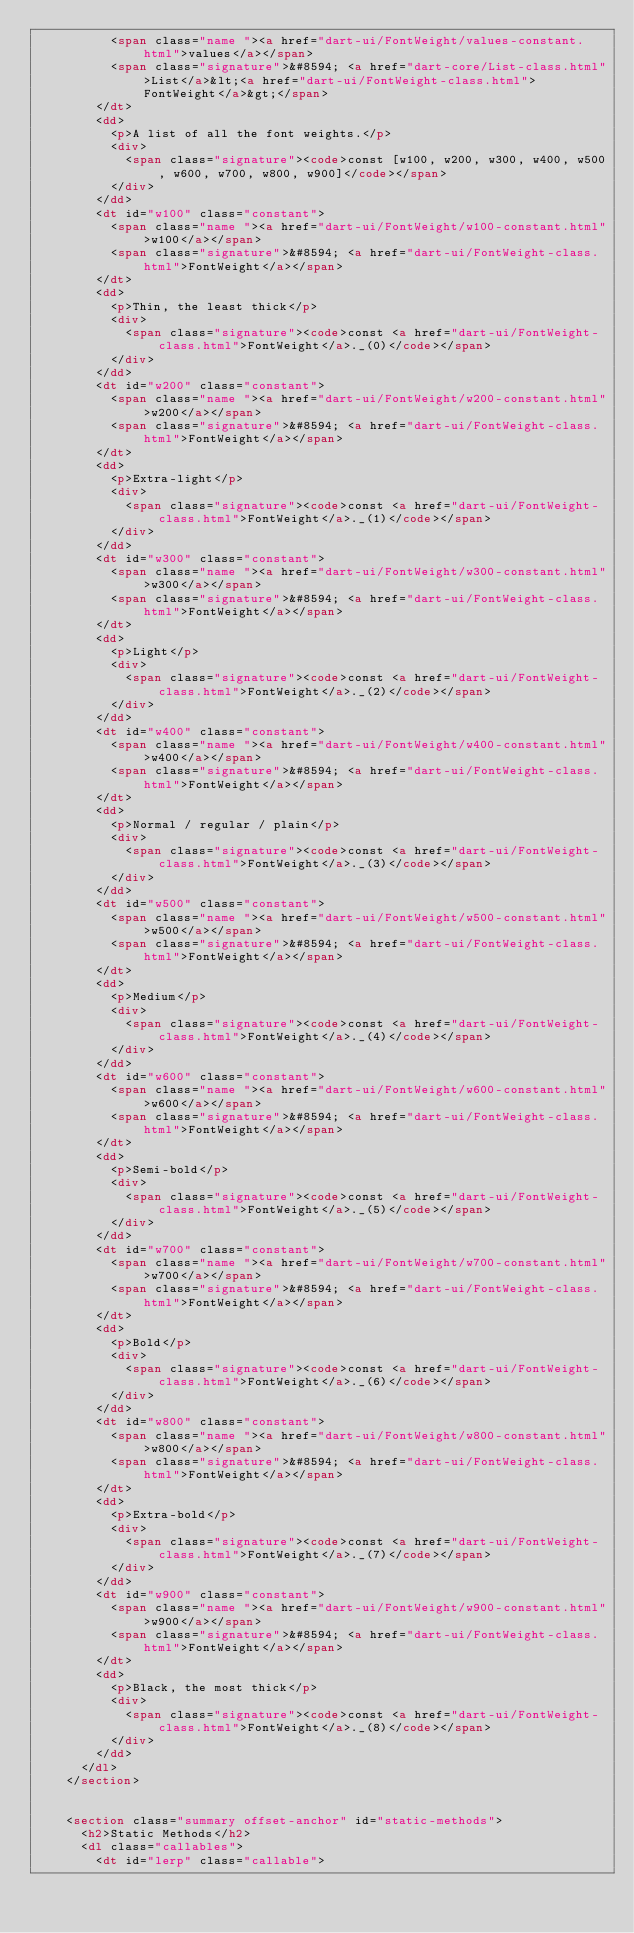Convert code to text. <code><loc_0><loc_0><loc_500><loc_500><_HTML_>          <span class="name "><a href="dart-ui/FontWeight/values-constant.html">values</a></span>
          <span class="signature">&#8594; <a href="dart-core/List-class.html">List</a>&lt;<a href="dart-ui/FontWeight-class.html">FontWeight</a>&gt;</span>
        </dt>
        <dd>
          <p>A list of all the font weights.</p>
          <div>
            <span class="signature"><code>const [w100, w200, w300, w400, w500, w600, w700, w800, w900]</code></span>
          </div>
        </dd>
        <dt id="w100" class="constant">
          <span class="name "><a href="dart-ui/FontWeight/w100-constant.html">w100</a></span>
          <span class="signature">&#8594; <a href="dart-ui/FontWeight-class.html">FontWeight</a></span>
        </dt>
        <dd>
          <p>Thin, the least thick</p>
          <div>
            <span class="signature"><code>const <a href="dart-ui/FontWeight-class.html">FontWeight</a>._(0)</code></span>
          </div>
        </dd>
        <dt id="w200" class="constant">
          <span class="name "><a href="dart-ui/FontWeight/w200-constant.html">w200</a></span>
          <span class="signature">&#8594; <a href="dart-ui/FontWeight-class.html">FontWeight</a></span>
        </dt>
        <dd>
          <p>Extra-light</p>
          <div>
            <span class="signature"><code>const <a href="dart-ui/FontWeight-class.html">FontWeight</a>._(1)</code></span>
          </div>
        </dd>
        <dt id="w300" class="constant">
          <span class="name "><a href="dart-ui/FontWeight/w300-constant.html">w300</a></span>
          <span class="signature">&#8594; <a href="dart-ui/FontWeight-class.html">FontWeight</a></span>
        </dt>
        <dd>
          <p>Light</p>
          <div>
            <span class="signature"><code>const <a href="dart-ui/FontWeight-class.html">FontWeight</a>._(2)</code></span>
          </div>
        </dd>
        <dt id="w400" class="constant">
          <span class="name "><a href="dart-ui/FontWeight/w400-constant.html">w400</a></span>
          <span class="signature">&#8594; <a href="dart-ui/FontWeight-class.html">FontWeight</a></span>
        </dt>
        <dd>
          <p>Normal / regular / plain</p>
          <div>
            <span class="signature"><code>const <a href="dart-ui/FontWeight-class.html">FontWeight</a>._(3)</code></span>
          </div>
        </dd>
        <dt id="w500" class="constant">
          <span class="name "><a href="dart-ui/FontWeight/w500-constant.html">w500</a></span>
          <span class="signature">&#8594; <a href="dart-ui/FontWeight-class.html">FontWeight</a></span>
        </dt>
        <dd>
          <p>Medium</p>
          <div>
            <span class="signature"><code>const <a href="dart-ui/FontWeight-class.html">FontWeight</a>._(4)</code></span>
          </div>
        </dd>
        <dt id="w600" class="constant">
          <span class="name "><a href="dart-ui/FontWeight/w600-constant.html">w600</a></span>
          <span class="signature">&#8594; <a href="dart-ui/FontWeight-class.html">FontWeight</a></span>
        </dt>
        <dd>
          <p>Semi-bold</p>
          <div>
            <span class="signature"><code>const <a href="dart-ui/FontWeight-class.html">FontWeight</a>._(5)</code></span>
          </div>
        </dd>
        <dt id="w700" class="constant">
          <span class="name "><a href="dart-ui/FontWeight/w700-constant.html">w700</a></span>
          <span class="signature">&#8594; <a href="dart-ui/FontWeight-class.html">FontWeight</a></span>
        </dt>
        <dd>
          <p>Bold</p>
          <div>
            <span class="signature"><code>const <a href="dart-ui/FontWeight-class.html">FontWeight</a>._(6)</code></span>
          </div>
        </dd>
        <dt id="w800" class="constant">
          <span class="name "><a href="dart-ui/FontWeight/w800-constant.html">w800</a></span>
          <span class="signature">&#8594; <a href="dart-ui/FontWeight-class.html">FontWeight</a></span>
        </dt>
        <dd>
          <p>Extra-bold</p>
          <div>
            <span class="signature"><code>const <a href="dart-ui/FontWeight-class.html">FontWeight</a>._(7)</code></span>
          </div>
        </dd>
        <dt id="w900" class="constant">
          <span class="name "><a href="dart-ui/FontWeight/w900-constant.html">w900</a></span>
          <span class="signature">&#8594; <a href="dart-ui/FontWeight-class.html">FontWeight</a></span>
        </dt>
        <dd>
          <p>Black, the most thick</p>
          <div>
            <span class="signature"><code>const <a href="dart-ui/FontWeight-class.html">FontWeight</a>._(8)</code></span>
          </div>
        </dd>
      </dl>
    </section>


    <section class="summary offset-anchor" id="static-methods">
      <h2>Static Methods</h2>
      <dl class="callables">
        <dt id="lerp" class="callable"></code> 